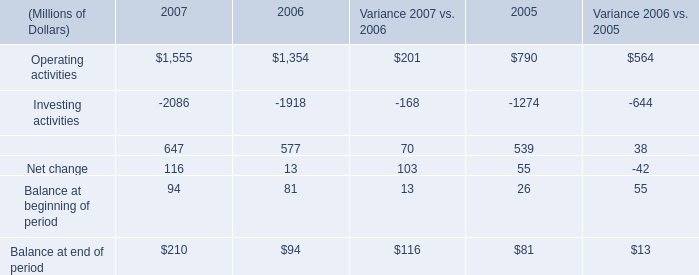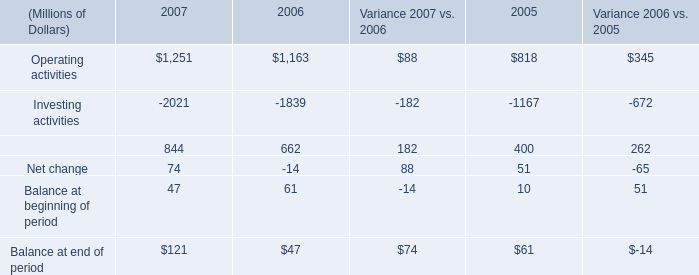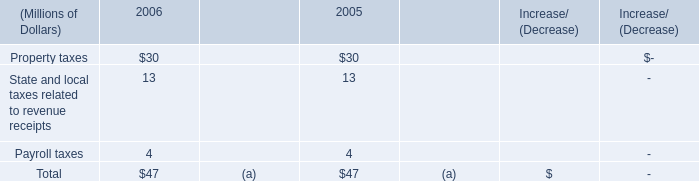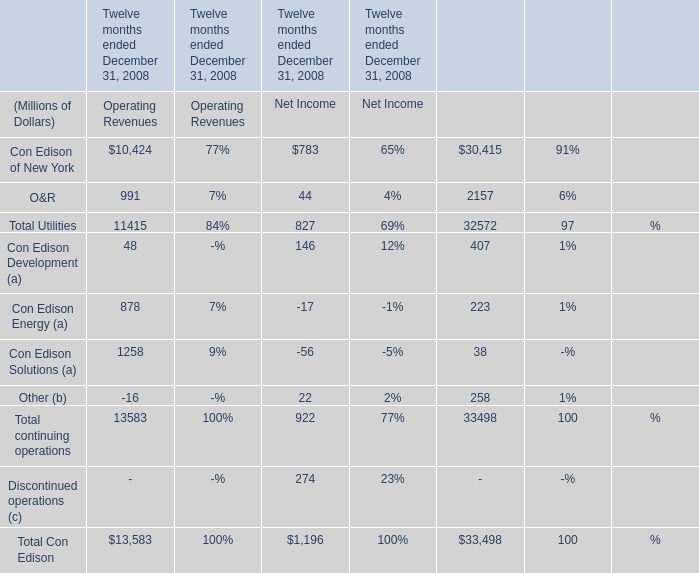for the sale of the 19 percent outside-operated interest in the corrib natural gas development offshore ireland , what is the total expected proceeds in millions? 
Computations: (100 + 135)
Answer: 235.0. 